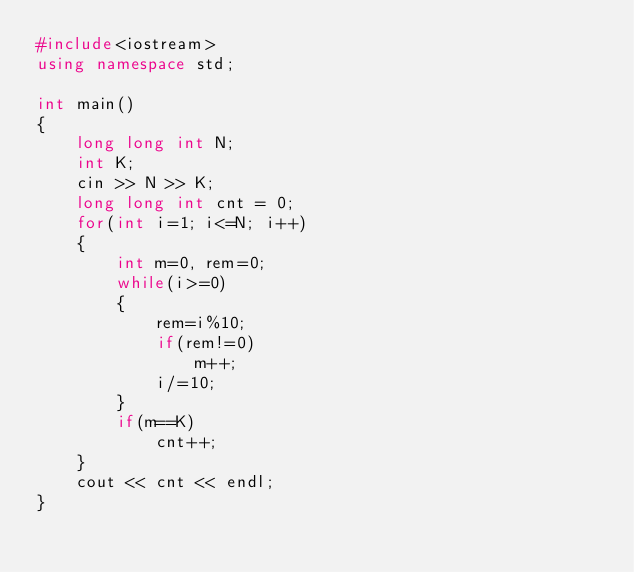<code> <loc_0><loc_0><loc_500><loc_500><_C++_>#include<iostream>
using namespace std;

int main()
{
    long long int N;
    int K;
    cin >> N >> K;
    long long int cnt = 0;
    for(int i=1; i<=N; i++)
    {
        int m=0, rem=0;
        while(i>=0)
        {
            rem=i%10;
            if(rem!=0)
                m++;
            i/=10;
        }
        if(m==K)
            cnt++;
    }
    cout << cnt << endl;
}
</code> 